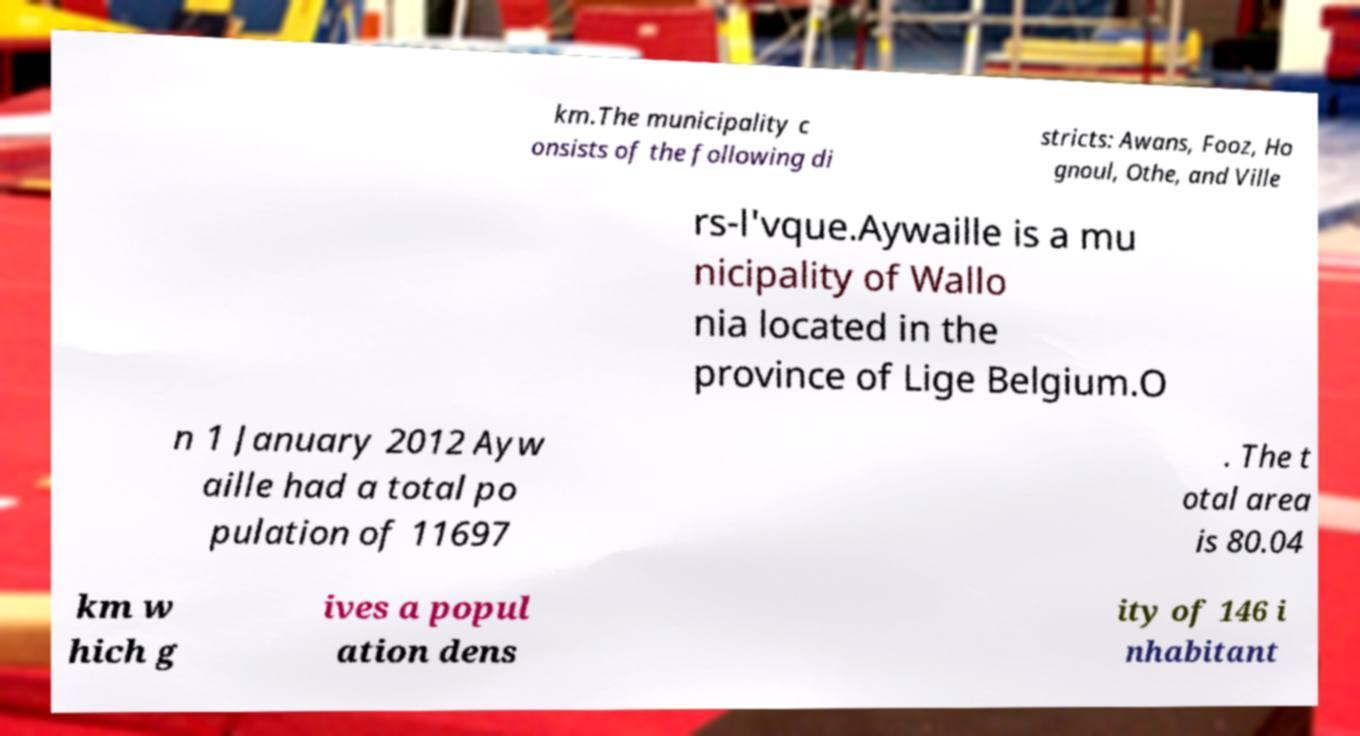Can you accurately transcribe the text from the provided image for me? km.The municipality c onsists of the following di stricts: Awans, Fooz, Ho gnoul, Othe, and Ville rs-l'vque.Aywaille is a mu nicipality of Wallo nia located in the province of Lige Belgium.O n 1 January 2012 Ayw aille had a total po pulation of 11697 . The t otal area is 80.04 km w hich g ives a popul ation dens ity of 146 i nhabitant 